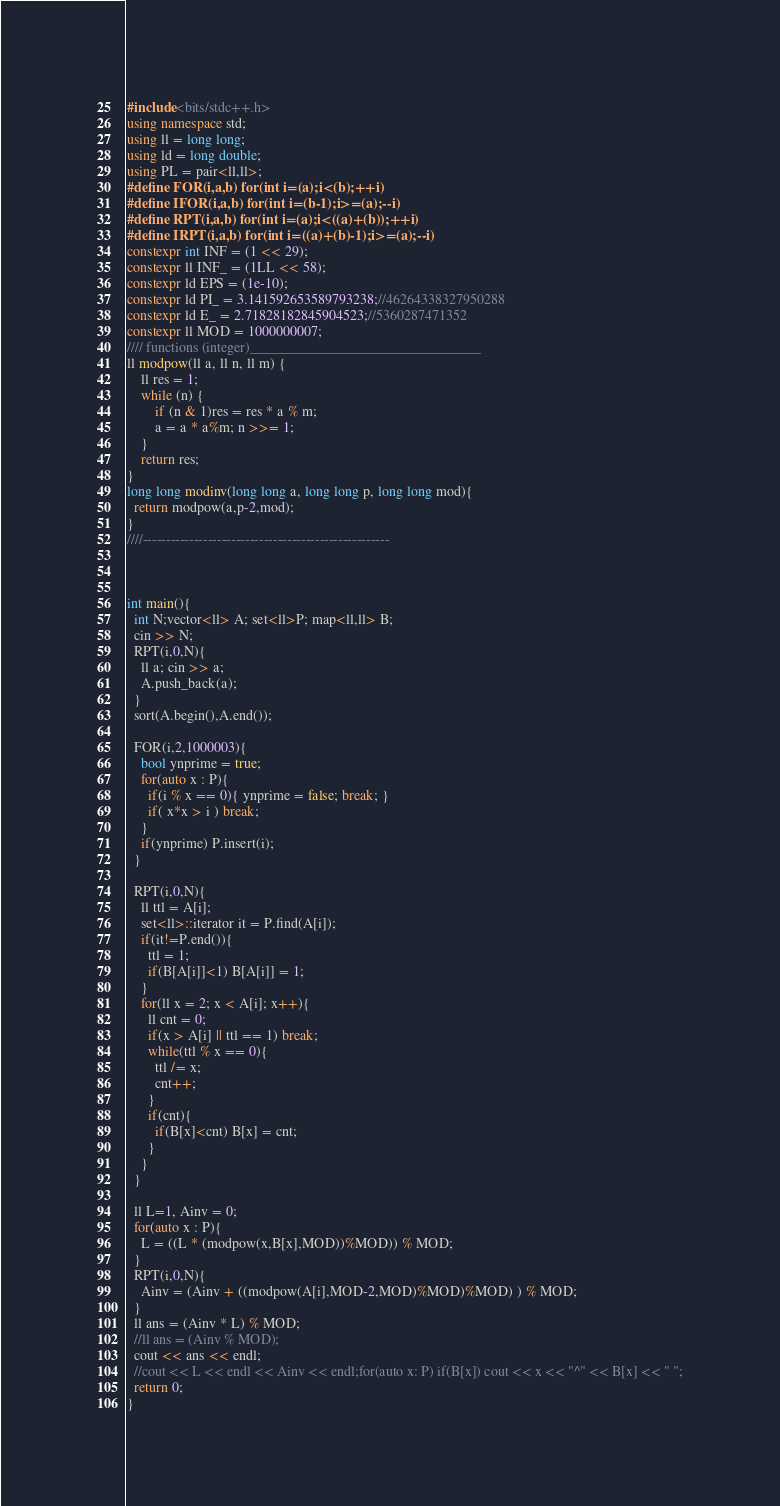Convert code to text. <code><loc_0><loc_0><loc_500><loc_500><_C++_>#include<bits/stdc++.h>
using namespace std;
using ll = long long;
using ld = long double;
using PL = pair<ll,ll>;
#define FOR(i,a,b) for(int i=(a);i<(b);++i)
#define IFOR(i,a,b) for(int i=(b-1);i>=(a);--i)
#define RPT(i,a,b) for(int i=(a);i<((a)+(b));++i)
#define IRPT(i,a,b) for(int i=((a)+(b)-1);i>=(a);--i)
constexpr int INF = (1 << 29);
constexpr ll INF_ = (1LL << 58);
constexpr ld EPS = (1e-10);
constexpr ld PI_ = 3.141592653589793238;//46264338327950288
constexpr ld E_ = 2.71828182845904523;//5360287471352
constexpr ll MOD = 1000000007;
//// functions (integer)_________________________________
ll modpow(ll a, ll n, ll m) {
	ll res = 1;
	while (n) {
		if (n & 1)res = res * a % m;
		a = a * a%m; n >>= 1;
	}
	return res;
}
long long modinv(long long a, long long p, long long mod){
  return modpow(a,p-2,mod);
}
////-----------------------------------------------------



int main(){
  int N;vector<ll> A; set<ll>P; map<ll,ll> B;
  cin >> N;
  RPT(i,0,N){
    ll a; cin >> a;
    A.push_back(a);
  }
  sort(A.begin(),A.end());

  FOR(i,2,1000003){
    bool ynprime = true;
    for(auto x : P){
      if(i % x == 0){ ynprime = false; break; }
      if( x*x > i ) break;
    }
    if(ynprime) P.insert(i);
  }

  RPT(i,0,N){
    ll ttl = A[i];
    set<ll>::iterator it = P.find(A[i]);
    if(it!=P.end()){
      ttl = 1;
      if(B[A[i]]<1) B[A[i]] = 1;
    }
    for(ll x = 2; x < A[i]; x++){
      ll cnt = 0;
      if(x > A[i] || ttl == 1) break;
      while(ttl % x == 0){
        ttl /= x;
        cnt++;
      }
      if(cnt){
        if(B[x]<cnt) B[x] = cnt;
      }
    }
  }

  ll L=1, Ainv = 0;
  for(auto x : P){
    L = ((L * (modpow(x,B[x],MOD))%MOD)) % MOD;
  }
  RPT(i,0,N){
    Ainv = (Ainv + ((modpow(A[i],MOD-2,MOD)%MOD)%MOD) ) % MOD;
  }
  ll ans = (Ainv * L) % MOD;
  //ll ans = (Ainv % MOD);
  cout << ans << endl; 
  //cout << L << endl << Ainv << endl;for(auto x: P) if(B[x]) cout << x << "^" << B[x] << " ";
  return 0;
}</code> 